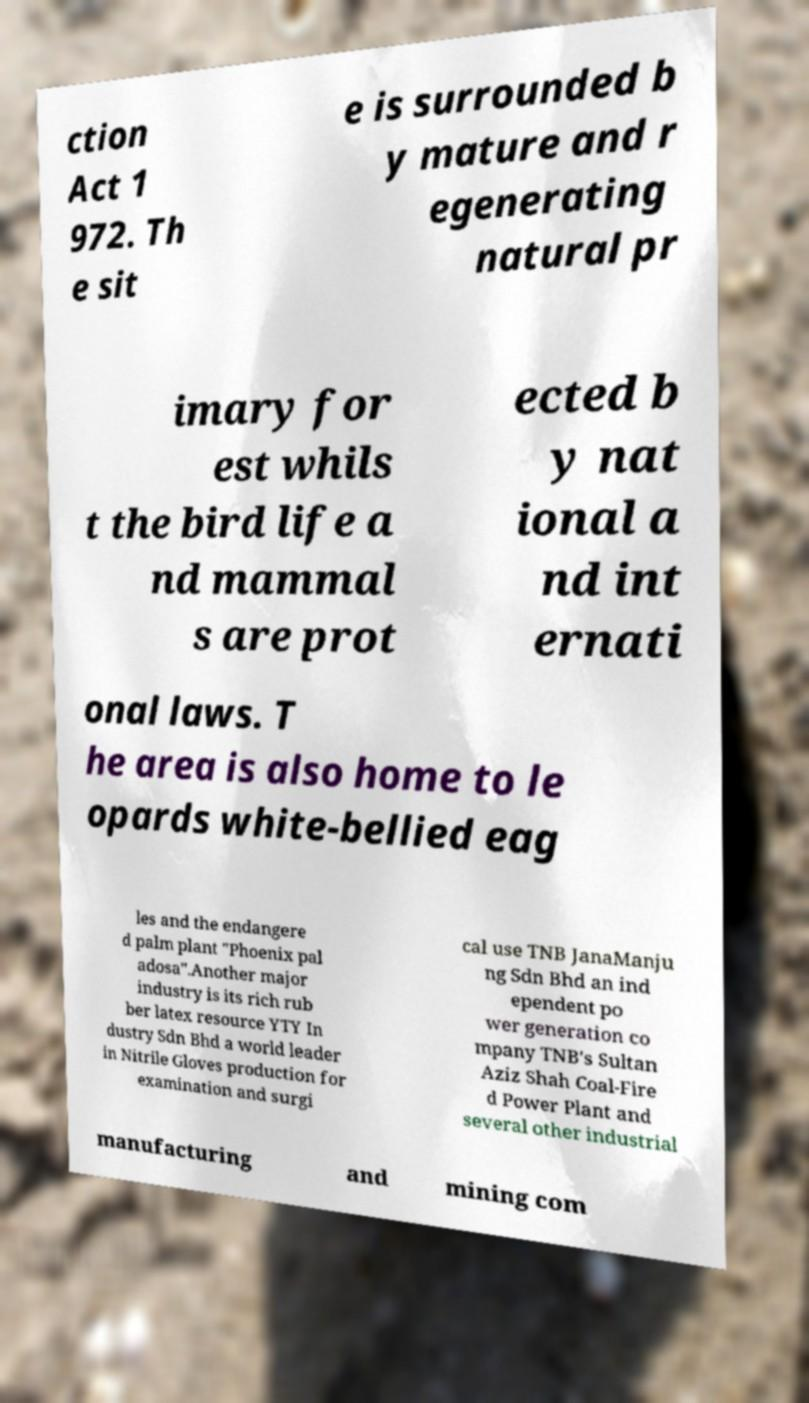I need the written content from this picture converted into text. Can you do that? ction Act 1 972. Th e sit e is surrounded b y mature and r egenerating natural pr imary for est whils t the bird life a nd mammal s are prot ected b y nat ional a nd int ernati onal laws. T he area is also home to le opards white-bellied eag les and the endangere d palm plant "Phoenix pal adosa".Another major industry is its rich rub ber latex resource YTY In dustry Sdn Bhd a world leader in Nitrile Gloves production for examination and surgi cal use TNB JanaManju ng Sdn Bhd an ind ependent po wer generation co mpany TNB's Sultan Aziz Shah Coal-Fire d Power Plant and several other industrial manufacturing and mining com 